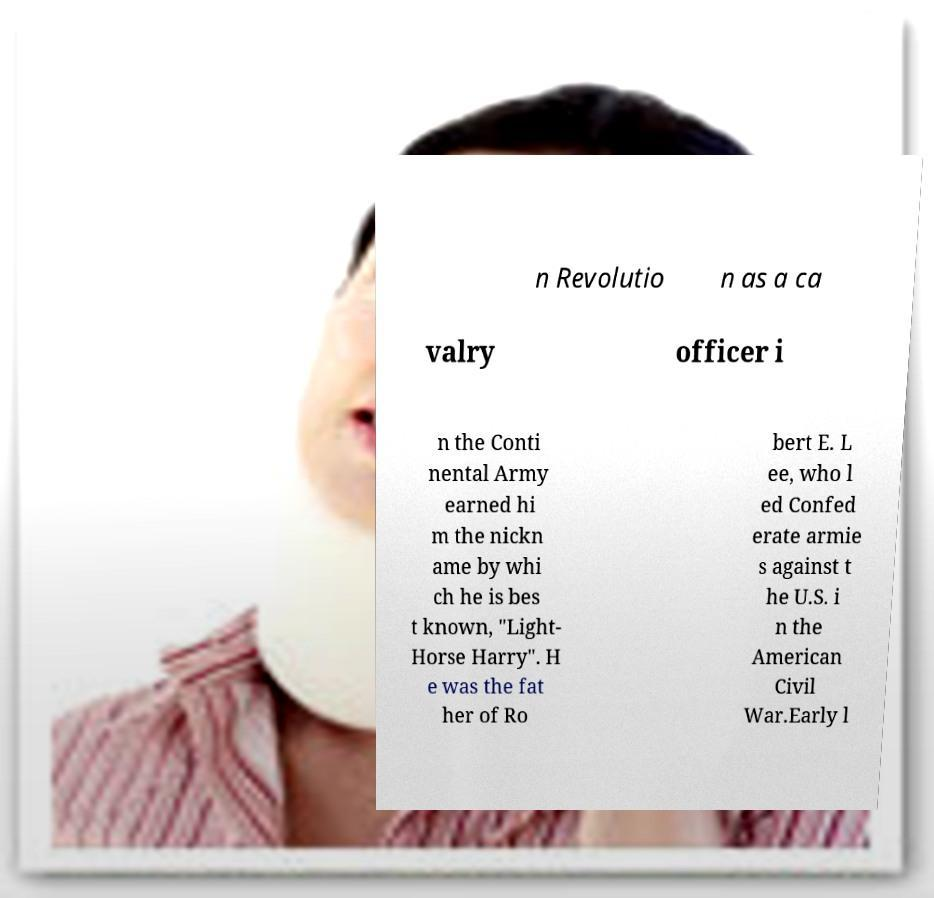Could you extract and type out the text from this image? n Revolutio n as a ca valry officer i n the Conti nental Army earned hi m the nickn ame by whi ch he is bes t known, "Light- Horse Harry". H e was the fat her of Ro bert E. L ee, who l ed Confed erate armie s against t he U.S. i n the American Civil War.Early l 